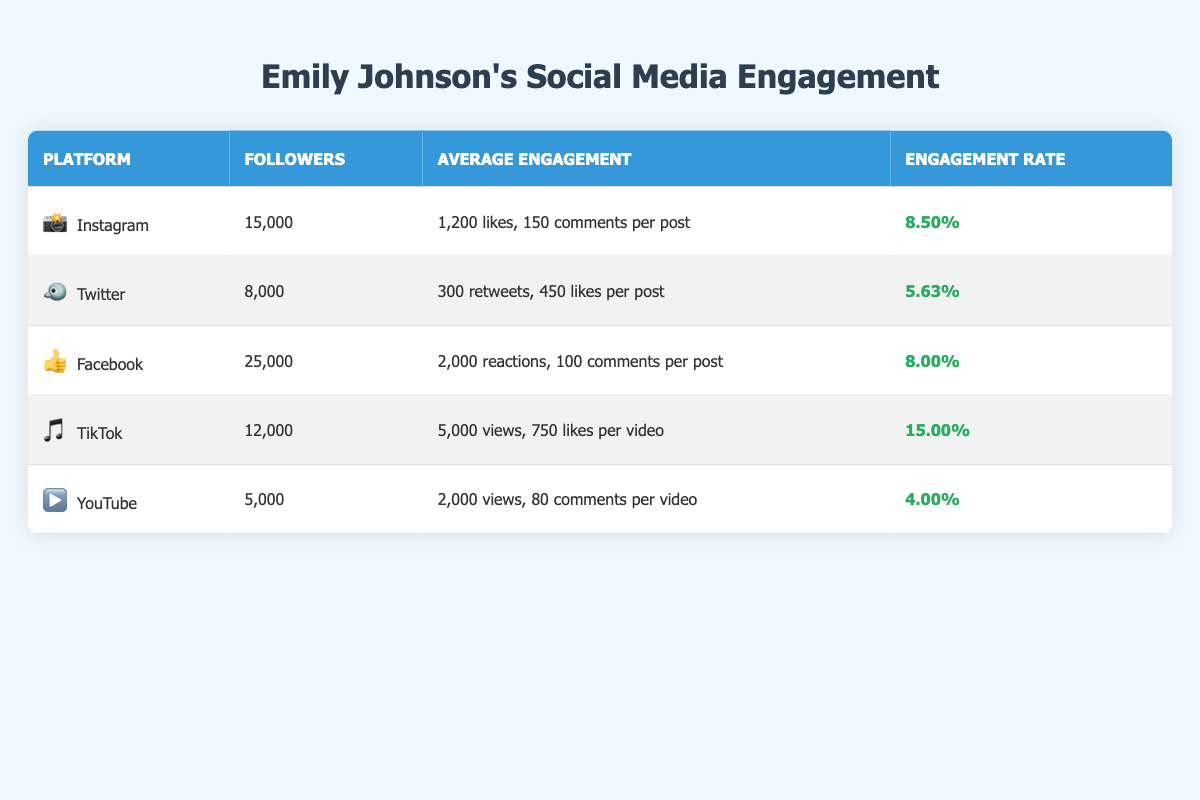What platform has the highest number of followers? According to the table, Facebook has 25,000 followers, which is higher than all other platforms listed.
Answer: Facebook What is the average likes per post on Instagram? The table states that the average likes per post on Instagram is 1,200.
Answer: 1,200 likes Which platform has the highest engagement rate? TikTok is listed with the highest engagement rate of 15.00%, compared to all other platforms.
Answer: TikTok How many more reactions per post does Facebook have compared to Twitter? Facebook has 2,000 reactions per post while Twitter has 450 likes per post. The difference is 2,000 - 450 = 1,550.
Answer: 1,550 What’s the total number of followers across all platforms? We can sum the followers for each platform: 15,000 (Instagram) + 8,000 (Twitter) + 25,000 (Facebook) + 12,000 (TikTok) + 5,000 (YouTube) = 65,000 followers total.
Answer: 65,000 followers Does TikTok have a higher average engagement rate than Instagram? TikTok has an engagement rate of 15.00%, while Instagram has an engagement rate of 8.50%. Therefore, TikTok does indeed have a higher engagement rate than Instagram.
Answer: Yes What is the average number of likes or reactions per post across all platforms? We calculate the average likes and reactions for Instagram, Twitter, Facebook, and TikTok as they include likes/reactions per post: (1,200 + 450 + 2,000 + 750) / 4 = 1,350 likes/reactions per post.
Answer: 1,350 likes/reactions Is Emily Johnson’s engagement rate on YouTube lower than that on Twitter? The engagement rate on YouTube is 4.00%, whereas the engagement rate on Twitter is 5.63%. Thus, YouTube's engagement rate is indeed lower than Twitter's.
Answer: Yes What is the difference in average comments per post between Instagram and Facebook? Instagram has 150 comments per post and Facebook has 100 comments per post, making the difference 150 - 100 = 50 comments per post.
Answer: 50 comments Which two platforms combined have the lowest total followers? YouTube has 5,000 followers and Twitter has 8,000 followers, giving a total of 5,000 + 8,000 = 13,000 followers combined, which is lower than any other combination.
Answer: 13,000 followers 